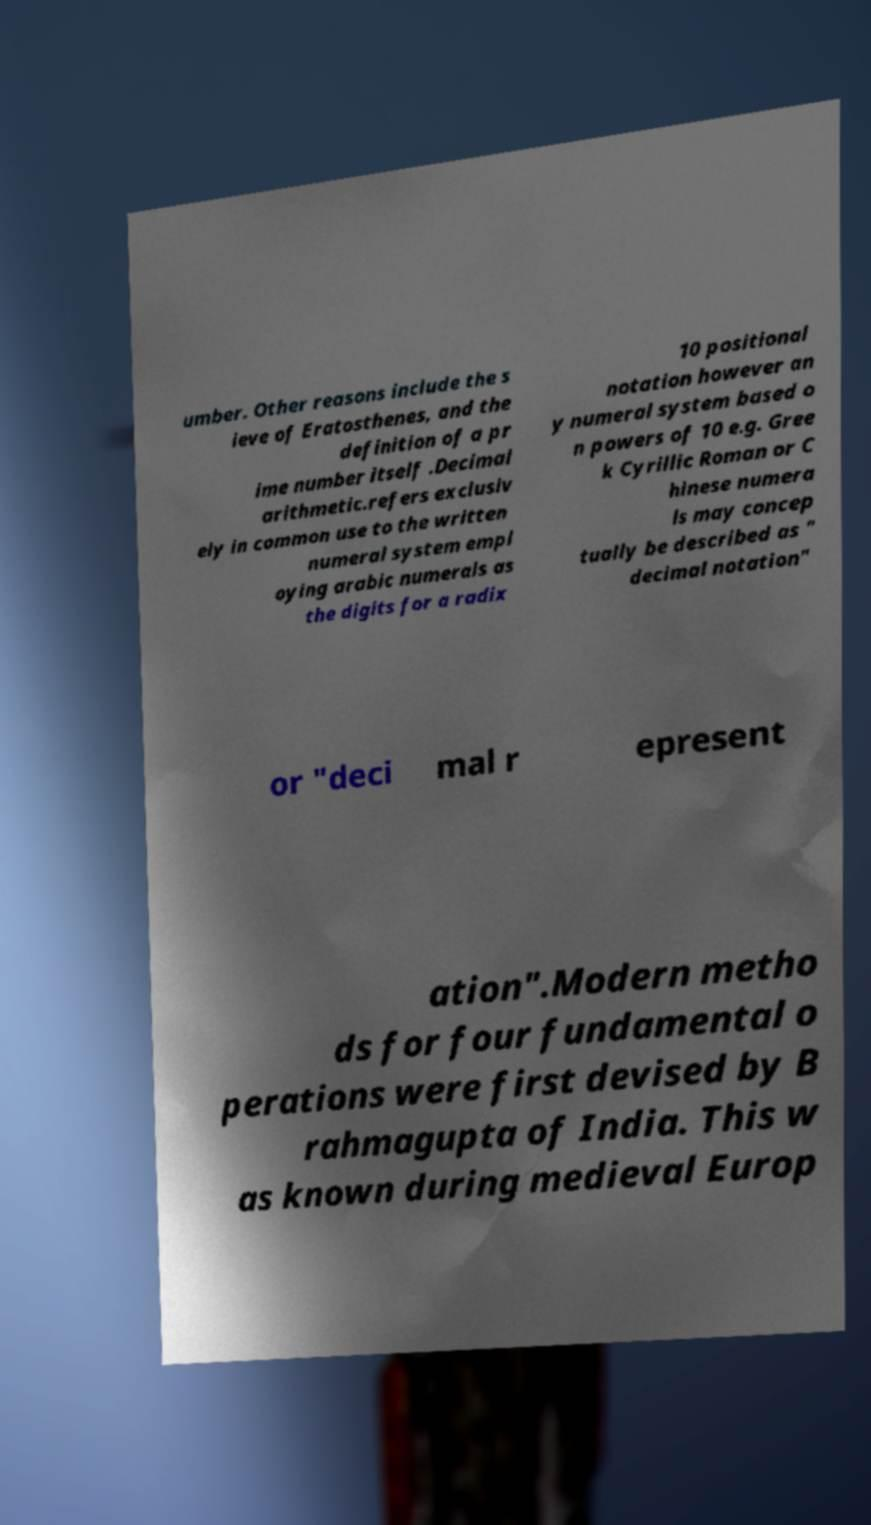There's text embedded in this image that I need extracted. Can you transcribe it verbatim? umber. Other reasons include the s ieve of Eratosthenes, and the definition of a pr ime number itself .Decimal arithmetic.refers exclusiv ely in common use to the written numeral system empl oying arabic numerals as the digits for a radix 10 positional notation however an y numeral system based o n powers of 10 e.g. Gree k Cyrillic Roman or C hinese numera ls may concep tually be described as " decimal notation" or "deci mal r epresent ation".Modern metho ds for four fundamental o perations were first devised by B rahmagupta of India. This w as known during medieval Europ 